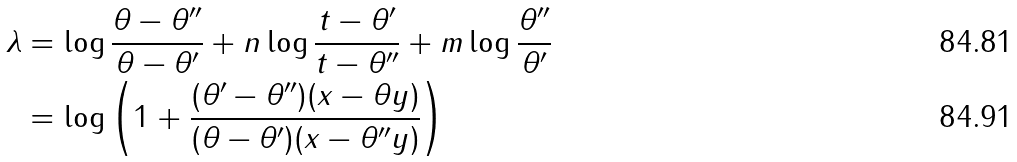<formula> <loc_0><loc_0><loc_500><loc_500>\lambda & = \log \frac { \theta - \theta ^ { \prime \prime } } { \theta - \theta ^ { \prime } } + n \log \frac { t - \theta ^ { \prime } } { t - \theta ^ { \prime \prime } } + m \log \frac { \theta ^ { \prime \prime } } { \theta ^ { \prime } } \\ & = \log \left ( 1 + \frac { ( \theta ^ { \prime } - \theta ^ { \prime \prime } ) ( x - \theta y ) } { ( \theta - \theta ^ { \prime } ) ( x - \theta ^ { \prime \prime } y ) } \right )</formula> 